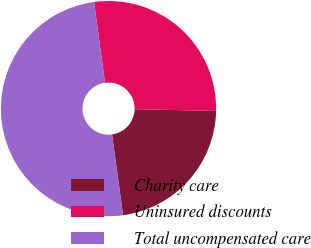Convert chart to OTSL. <chart><loc_0><loc_0><loc_500><loc_500><pie_chart><fcel>Charity care<fcel>Uninsured discounts<fcel>Total uncompensated care<nl><fcel>22.5%<fcel>27.5%<fcel>50.0%<nl></chart> 